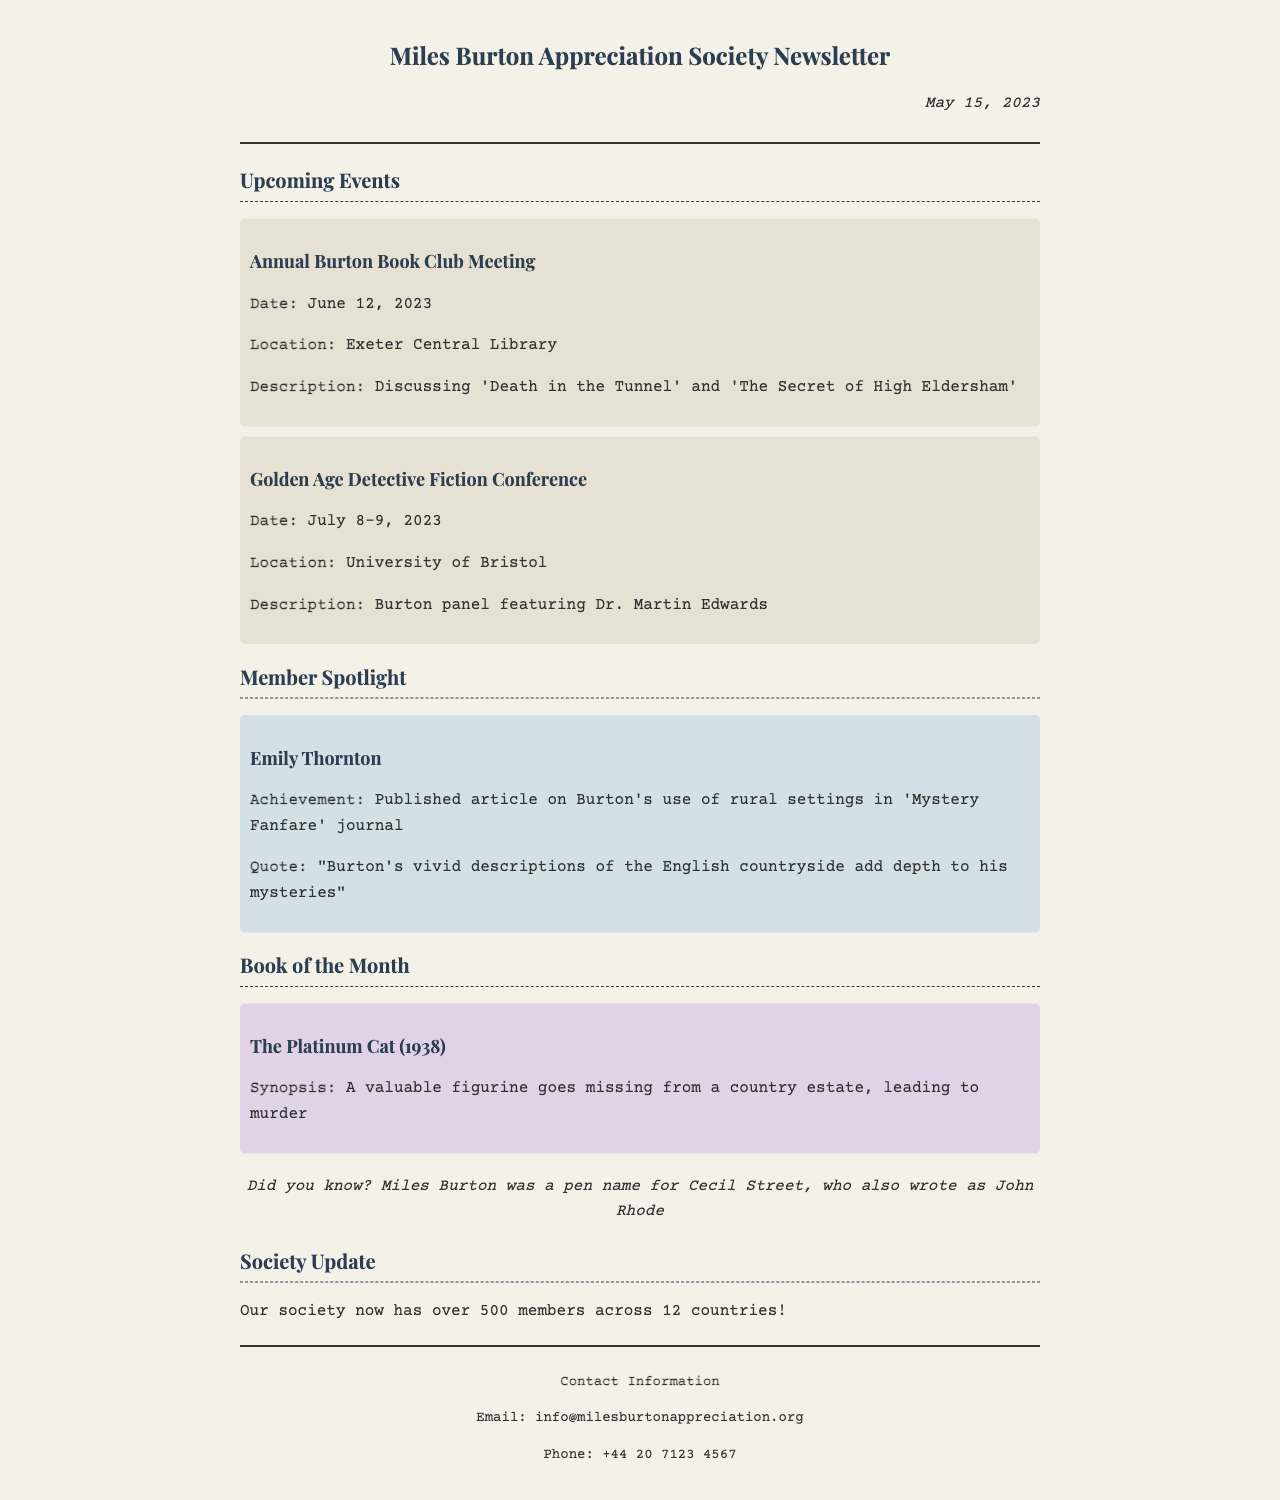What is the date of the newsletter? The date is mentioned at the beginning of the document in the header section.
Answer: May 15, 2023 Where is the Annual Burton Book Club Meeting held? The location of the event is specified in the event description.
Answer: Exeter Central Library What is the focus of the 'Golden Age Detective Fiction Conference'? The description of the event indicates the topic of discussion for the panel.
Answer: Burton panel featuring Dr. Martin Edwards Who is spotlighted in the member section? The member spotlight section includes the name of the highlighted member.
Answer: Emily Thornton What is the title of the Book of the Month? The title is presented in the book section of the newsletter.
Answer: The Platinum Cat (1938) What significant fact is mentioned about Miles Burton? The fact section provides an interesting detail about the author.
Answer: A pen name for Cecil Street What is the membership count of the society? The document provides the total number of members at the end of the newsletter.
Answer: Over 500 members What is the reason for the Annual Burton Book Club Meeting? The document explains the purpose for which the club is meeting.
Answer: Discussing 'Death in the Tunnel' and 'The Secret of High Eldersham' What is the date range for the Golden Age Detective Fiction Conference? The event description specifies the dates for this conference.
Answer: July 8-9, 2023 